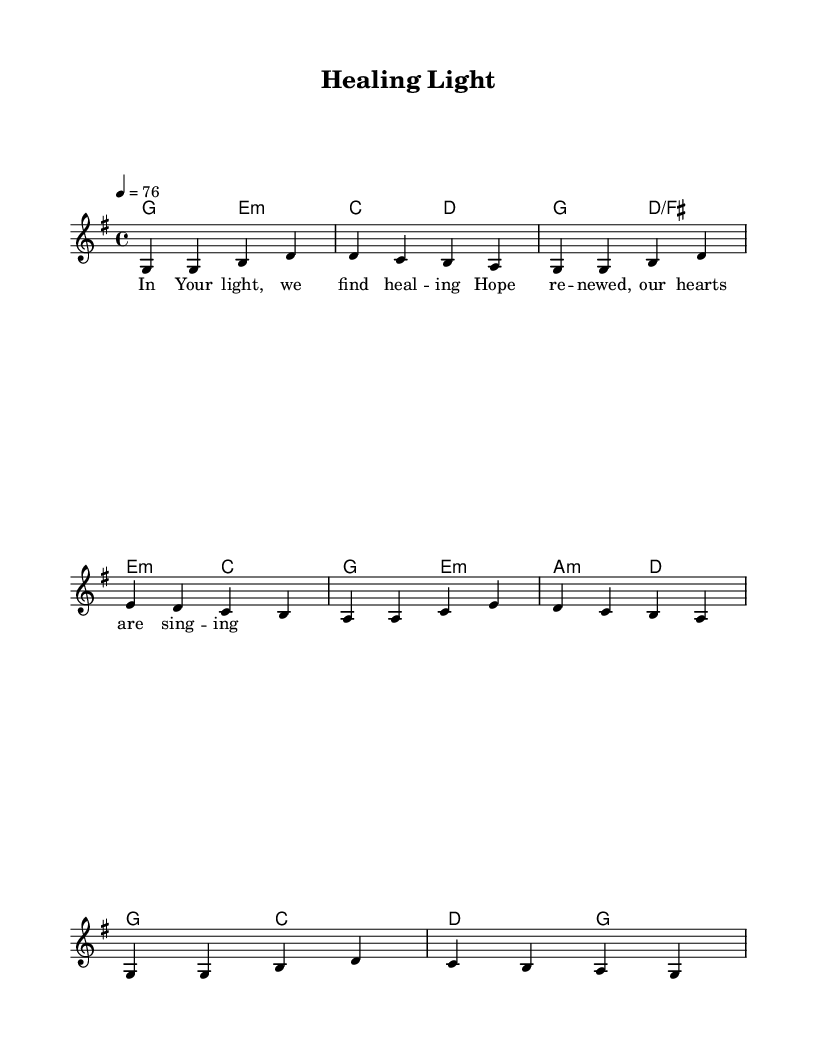What is the key signature of this music? The key signature is G major, which has one sharp (F#).
Answer: G major What is the time signature of this music? The time signature is 4/4, indicating four beats per measure.
Answer: 4/4 What is the tempo marking for this piece? The tempo marking indicates a speed of 76 beats per minute, given in the tempo directive.
Answer: 76 How many measures are in the melody? The melody contains eight measures, as indicated by the structure and layout of the notes.
Answer: Eight What is the primary theme of the lyrics? The primary theme of the lyrics revolves around healing and hope, as suggested by the lines.
Answer: Healing and hope What chord follows the A minor chord in the harmonies? The chord that follows A minor in the harmonies is D major, which appears in the sequence.
Answer: D major Which word signifies the renewal of hope in the lyrics? The word "renewed" signifies the renewal of hope in the lyrics, highlighting the theme.
Answer: Renewed 